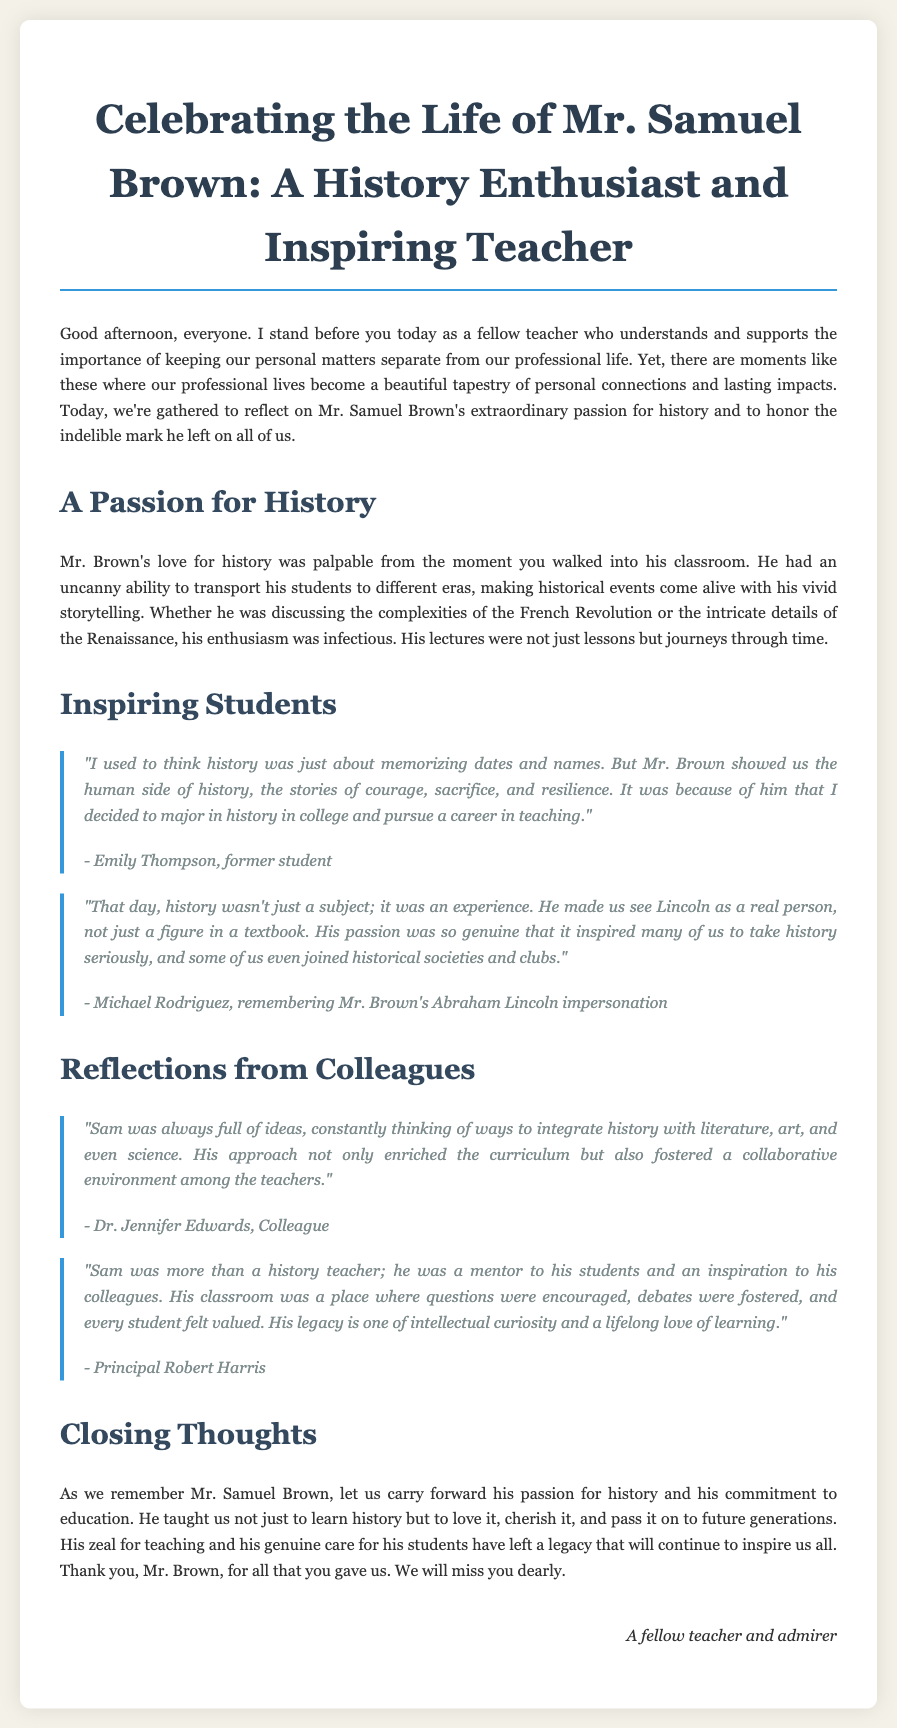What was Mr. Brown's full name? The document mentions his full name as Mr. Samuel Brown.
Answer: Mr. Samuel Brown What subject did Mr. Brown teach? The eulogy indicates that he was a history teacher.
Answer: History Who is quoted saying, "I decided to major in history in college"? The quote is attributed to Emily Thompson, a former student.
Answer: Emily Thompson What did Michael Rodriguez remember Mr. Brown impersonating? He remembered Mr. Brown's impersonation of Abraham Lincoln.
Answer: Abraham Lincoln Who described Mr. Brown as a mentor to his students? Principal Robert Harris referred to Mr. Brown as a mentor.
Answer: Principal Robert Harris What kind of environment did Mr. Brown foster among teachers? Dr. Jennifer Edwards stated that he fostered a collaborative environment.
Answer: Collaborative What legacy did Mr. Brown leave, as mentioned in the eulogy? The document notes his legacy is one of intellectual curiosity and a lifelong love of learning.
Answer: Intellectual curiosity and a lifelong love of learning How did Mr. Brown's students view history before his teaching? Students initially thought history was just about memorizing dates and names.
Answer: Memorizing dates and names What was Mr. Brown's approach to integrating different subjects? He constantly thought of ways to integrate history with literature, art, and science.
Answer: Integrate history with literature, art, and science 